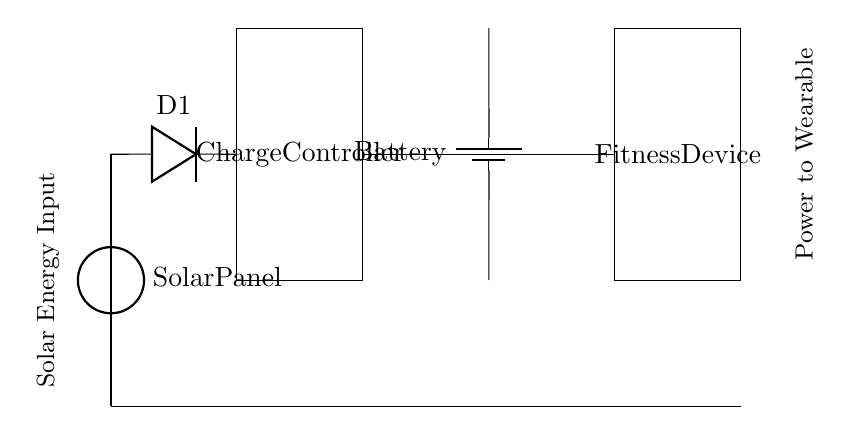What type of energy does the circuit use? The circuit utilizes solar energy, as indicated by the solar panel at the start of the circuit diagram. The solar panel converts sunlight into electrical energy.
Answer: Solar energy How many main components are in this circuit? The circuit consists of five main components: a solar panel, a blocking diode, a charge controller, a battery, and a fitness device as the load.
Answer: Five What is the role of the blocking diode in the circuit? The blocking diode prevents the reverse flow of current from the battery back to the solar panel when there's no sunlight. This ensures that the battery does not discharge back into the panel, protecting the components.
Answer: Prevent reverse current What happens if the battery is fully charged? When the battery is fully charged, the charge controller regulates the current to prevent overcharging, which could damage the battery. This is an important function to prolong battery life and maintain safety.
Answer: Regulates current Which component regulates power to the fitness device? The charge controller controls the flow of power to the fitness device, ensuring that it receives the appropriate voltage and current based on the battery charge state. This helps protect both the device and the battery from damage.
Answer: Charge controller 